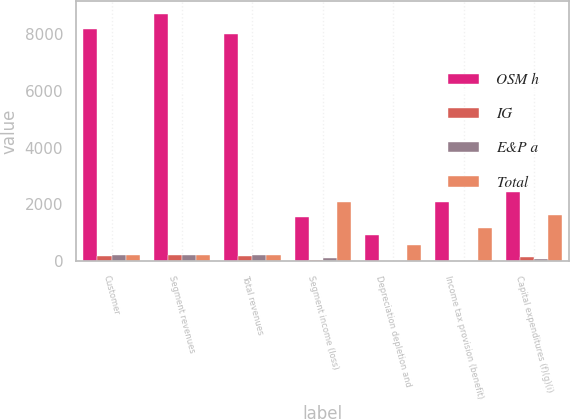Convert chart. <chart><loc_0><loc_0><loc_500><loc_500><stacked_bar_chart><ecel><fcel>Customer<fcel>Segment revenues<fcel>Total revenues<fcel>Segment income (loss)<fcel>Depreciation depletion and<fcel>Income tax provision (benefit)<fcel>Capital expenditures (f)(g)(i)<nl><fcel>OSM h<fcel>8167<fcel>8699<fcel>7970<fcel>1552<fcel>914<fcel>2076<fcel>2426<nl><fcel>IG<fcel>181<fcel>221<fcel>181<fcel>63<fcel>22<fcel>21<fcel>165<nl><fcel>E&P a<fcel>218<fcel>218<fcel>218<fcel>132<fcel>6<fcel>24<fcel>93<nl><fcel>Total<fcel>218<fcel>218<fcel>218<fcel>2077<fcel>587<fcel>1183<fcel>1640<nl></chart> 